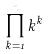<formula> <loc_0><loc_0><loc_500><loc_500>\prod _ { k = 1 } ^ { n } k ^ { k }</formula> 